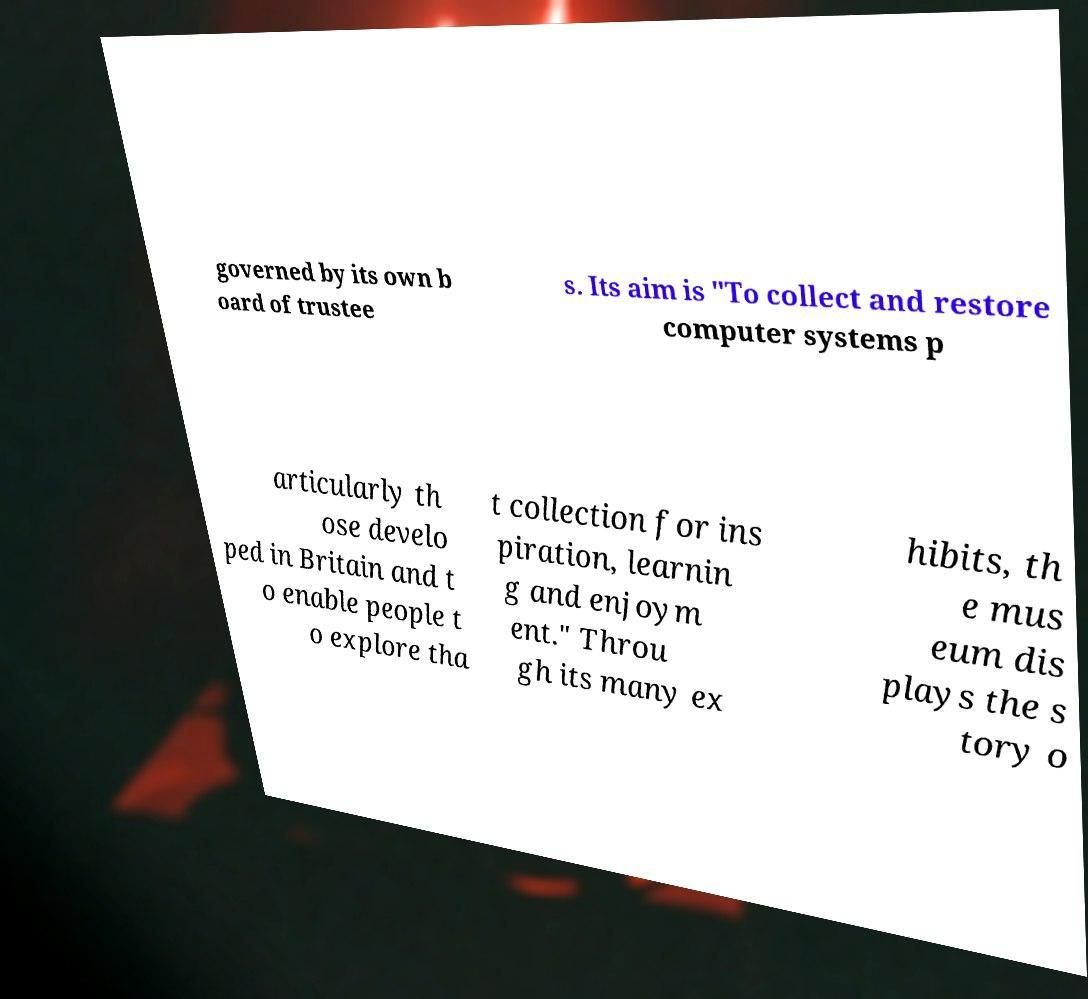Can you accurately transcribe the text from the provided image for me? governed by its own b oard of trustee s. Its aim is "To collect and restore computer systems p articularly th ose develo ped in Britain and t o enable people t o explore tha t collection for ins piration, learnin g and enjoym ent." Throu gh its many ex hibits, th e mus eum dis plays the s tory o 